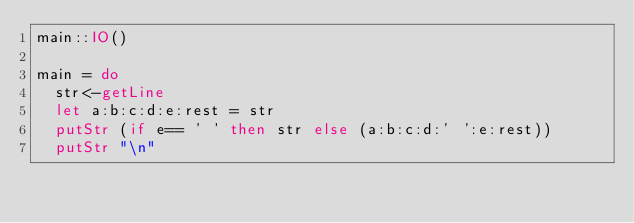Convert code to text. <code><loc_0><loc_0><loc_500><loc_500><_Haskell_>main::IO()

main = do
  str<-getLine
  let a:b:c:d:e:rest = str
  putStr (if e== ' ' then str else (a:b:c:d:' ':e:rest))
  putStr "\n"
</code> 